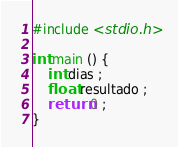Convert code to text. <code><loc_0><loc_0><loc_500><loc_500><_C++_>#include <stdio.h>

int main () {
	int dias ;
	float resultado ;
	return 0 ;
}
</code> 